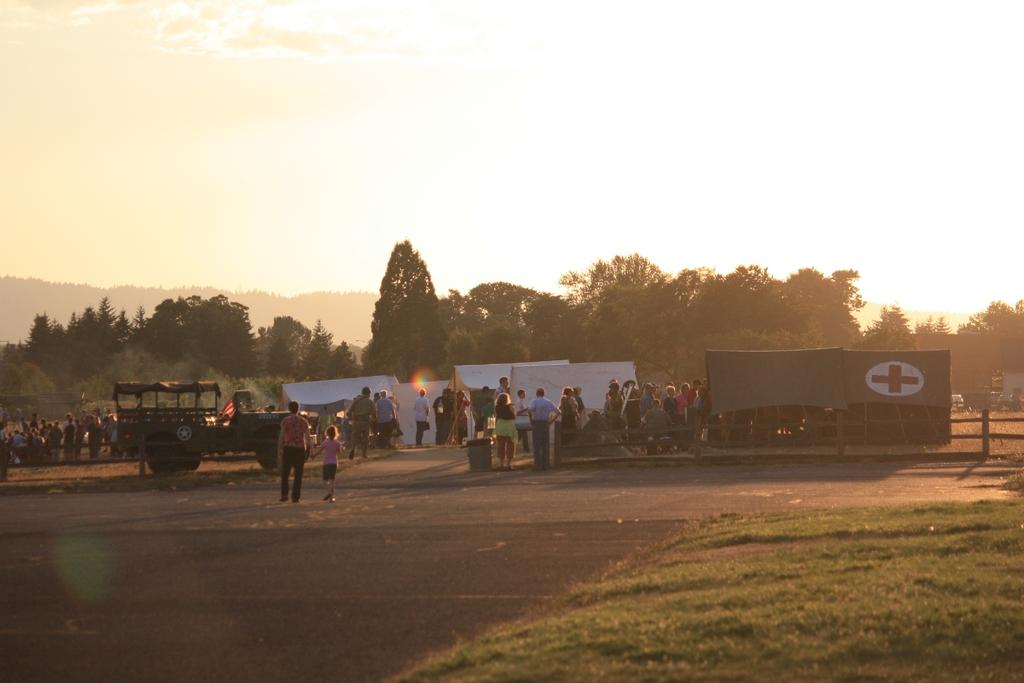What is there is a vehicle on the left side of the image, what type of vehicle is it? The fact does not specify the type of vehicle, only that there is a vehicle on the left side of the image. What are the people in the middle of the image doing? The fact only mentions that there are people in the middle of the image, but it does not describe their actions or activities. What kind of trees can be seen in the background of the image? The fact only mentions that there are trees in the background of the image, but it does not describe the type of trees. What is the color of the sky visible at the top of the image? The fact only mentions that the sky is visible at the top of the image, but it does not describe the color of the sky. Can you tell me how many cannons are depicted in the news on the right side of the image? There is no mention of cannons, news, or a right side of the image in the provided facts. 